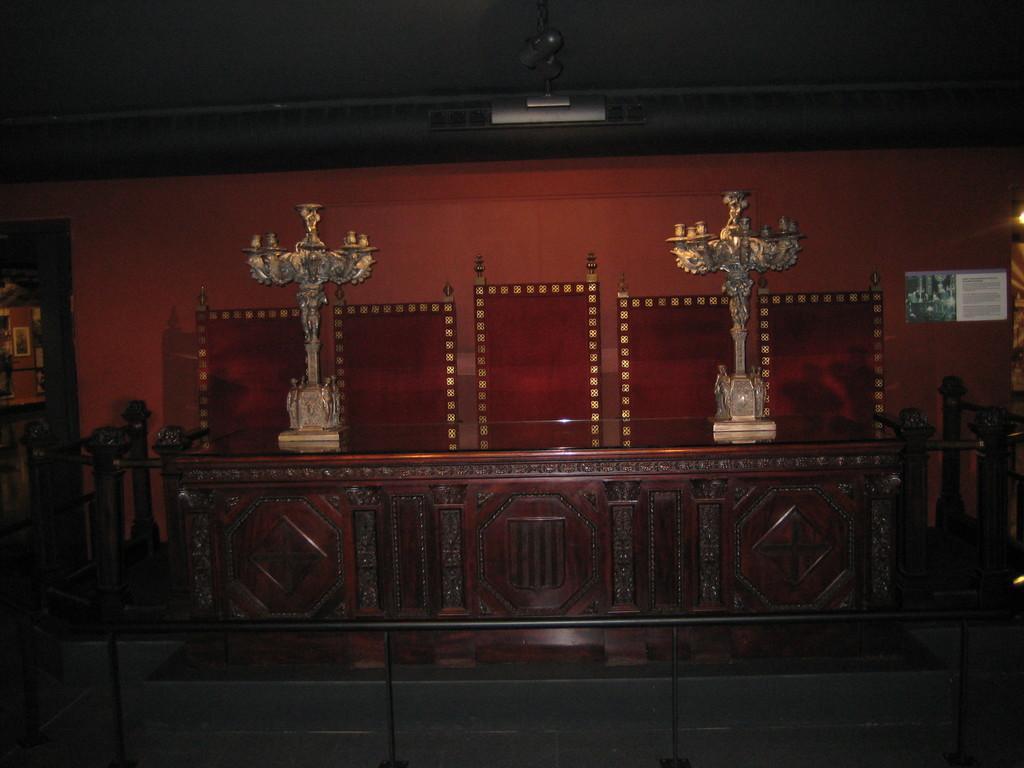Could you give a brief overview of what you see in this image? In this image in front there is a metal fence. In the center of the image there is a wooden desk. On top of it there are two objects. Behind the table there are chairs. In the background of the image there is a wall with the poster on it. On the right side of the image there is a light. 